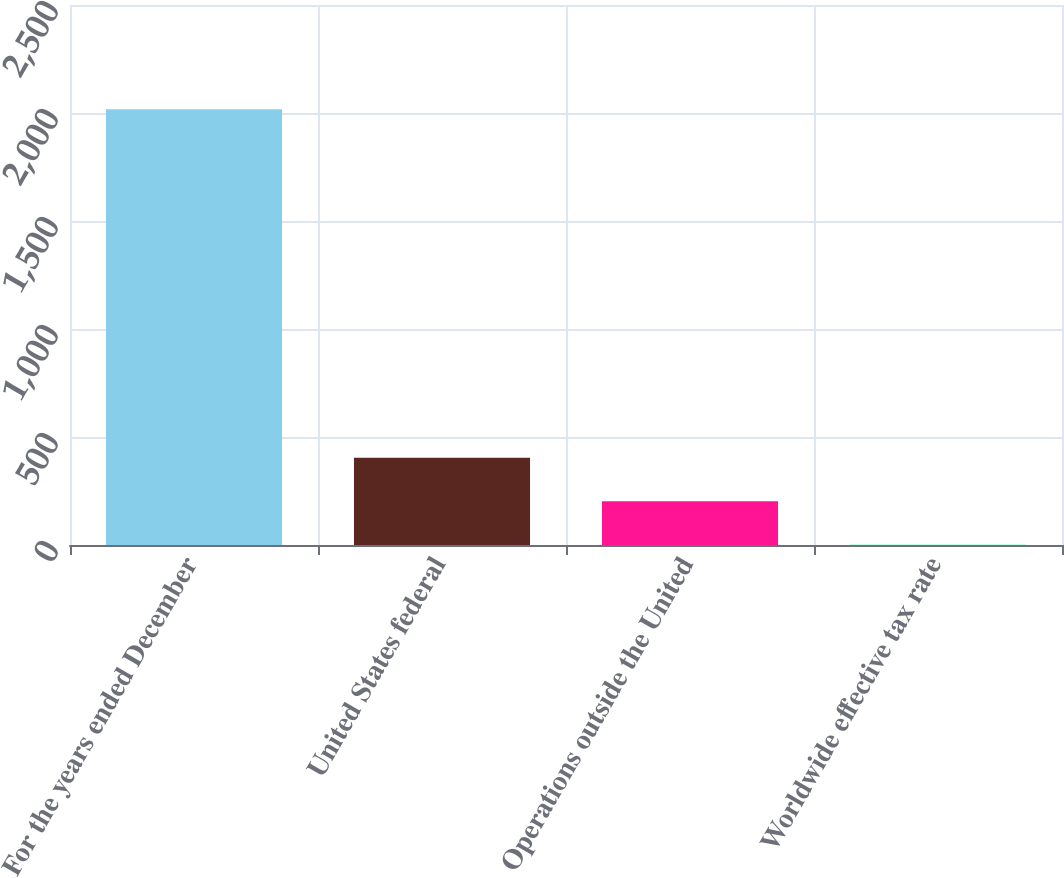Convert chart. <chart><loc_0><loc_0><loc_500><loc_500><bar_chart><fcel>For the years ended December<fcel>United States federal<fcel>Operations outside the United<fcel>Worldwide effective tax rate<nl><fcel>2017<fcel>404.2<fcel>202.6<fcel>1<nl></chart> 